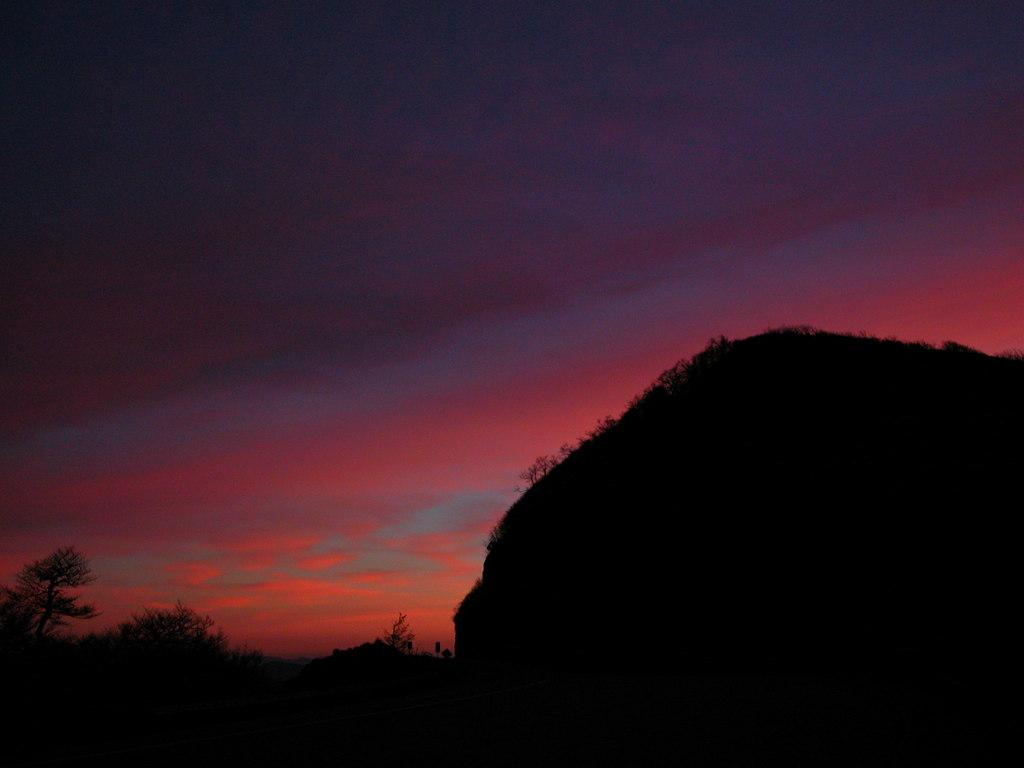What type of vegetation is present at the bottom of the image? There are trees at the bottom of the image. What geographical feature is also present at the bottom of the image? There is a mountain at the bottom of the image. What is visible at the top of the image? The sky is visible at the top of the image. How many additions can be seen in the image? There is no mention of any additions in the image, so it is not possible to answer this question. 